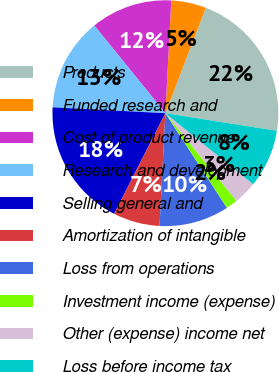Convert chart to OTSL. <chart><loc_0><loc_0><loc_500><loc_500><pie_chart><fcel>Products<fcel>Funded research and<fcel>Cost of product revenue<fcel>Research and development<fcel>Selling general and<fcel>Amortization of intangible<fcel>Loss from operations<fcel>Investment income (expense)<fcel>Other (expense) income net<fcel>Loss before income tax<nl><fcel>21.67%<fcel>5.0%<fcel>11.67%<fcel>13.33%<fcel>18.33%<fcel>6.67%<fcel>10.0%<fcel>1.67%<fcel>3.33%<fcel>8.33%<nl></chart> 